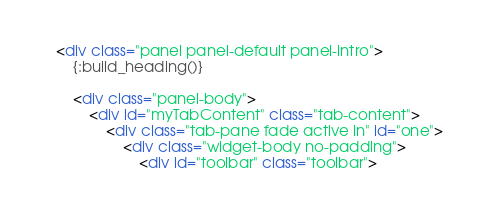Convert code to text. <code><loc_0><loc_0><loc_500><loc_500><_HTML_><div class="panel panel-default panel-intro">
    {:build_heading()}

    <div class="panel-body">
        <div id="myTabContent" class="tab-content">
            <div class="tab-pane fade active in" id="one">
                <div class="widget-body no-padding">
                    <div id="toolbar" class="toolbar"></code> 